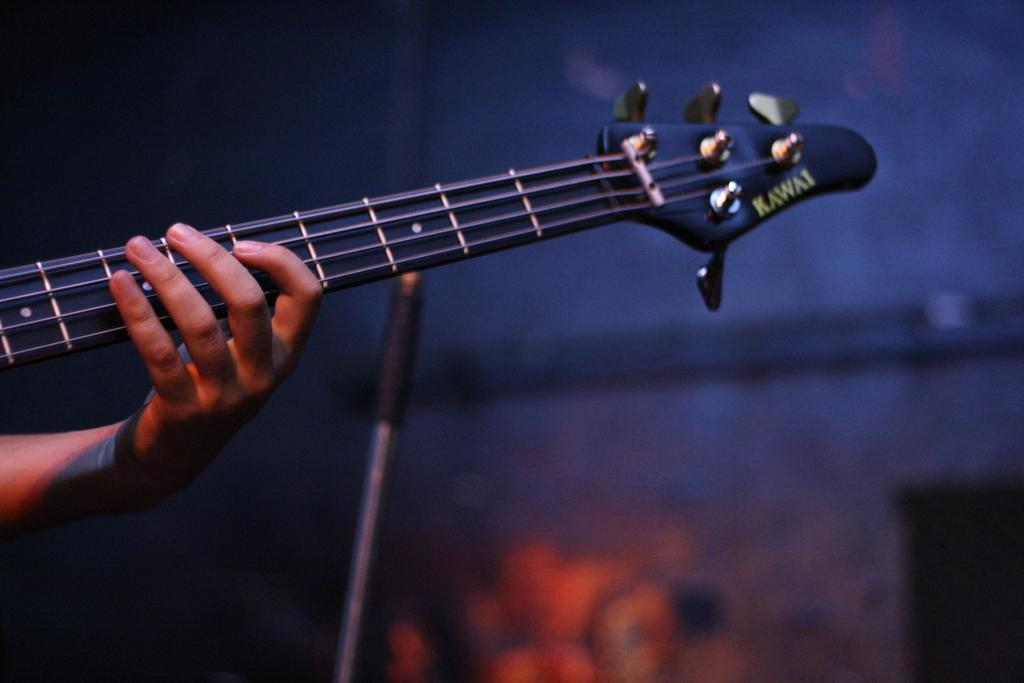What is the person holding in the image? There is a person's hand holding a guitar in the image. What can be seen in the background of the image? There is a pole, a light, and a wall in the background of the image. What type of map is the person using to play the guitar in the image? There is no map present in the image, and the person is not using any map to play the guitar. 